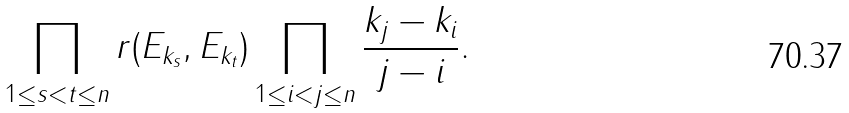<formula> <loc_0><loc_0><loc_500><loc_500>\prod _ { 1 \leq s < t \leq n } r ( E _ { k _ { s } } , E _ { k _ { t } } ) \prod _ { 1 \leq i < j \leq n } \frac { k _ { j } - k _ { i } } { j - i } .</formula> 